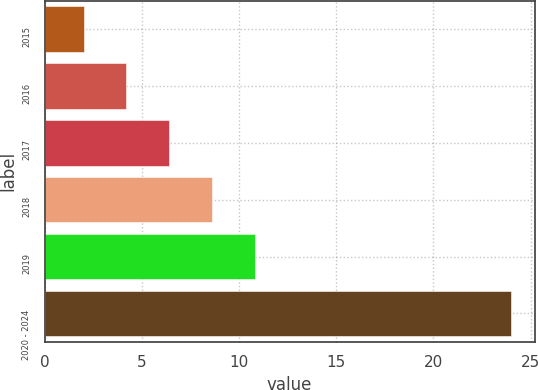Convert chart. <chart><loc_0><loc_0><loc_500><loc_500><bar_chart><fcel>2015<fcel>2016<fcel>2017<fcel>2018<fcel>2019<fcel>2020 - 2024<nl><fcel>2<fcel>4.2<fcel>6.4<fcel>8.6<fcel>10.8<fcel>24<nl></chart> 